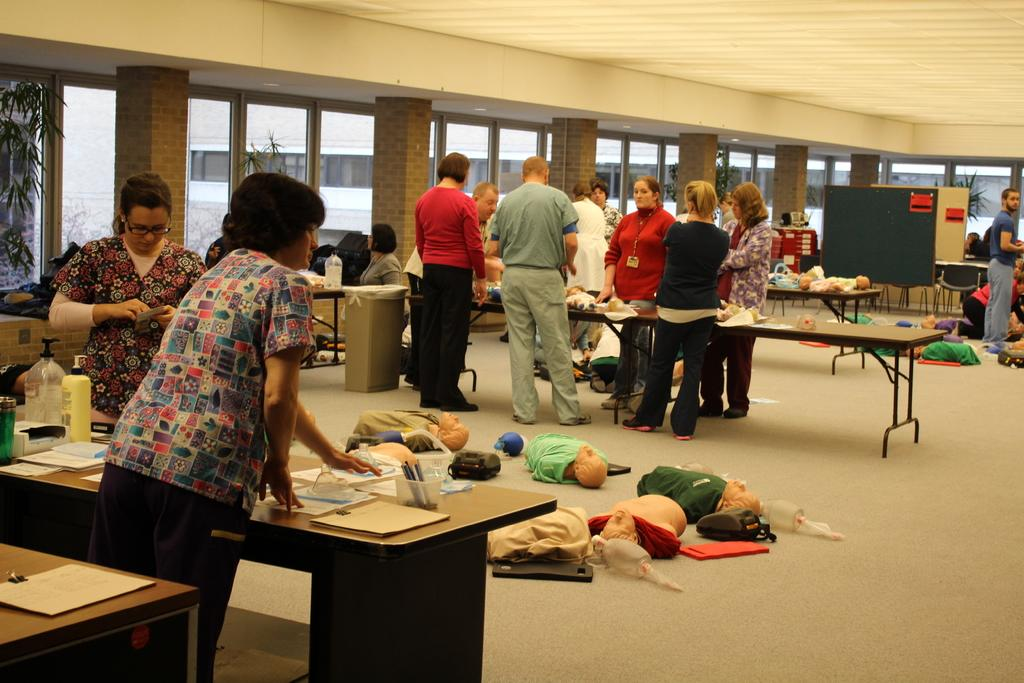How many people are in the image? There is a group of people in the image, but the exact number cannot be determined from the provided facts. What is on the floor in the image? There are toys on the floor in the image. What can be seen in the background of the image? There are poles, windows, and plants in the background of the image. How many pigs are visible in the image? There are no pigs present in the image. What type of team is playing in the image? There is no indication of a team or any sports activity in the image. 